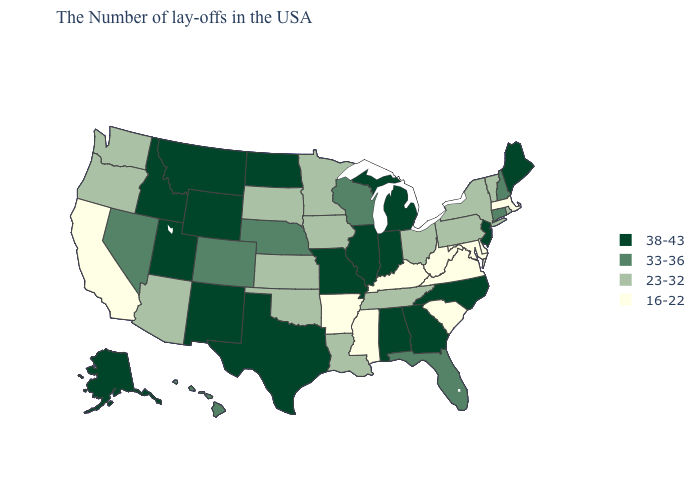What is the lowest value in the USA?
Quick response, please. 16-22. Does Pennsylvania have the lowest value in the USA?
Give a very brief answer. No. How many symbols are there in the legend?
Short answer required. 4. Does New Hampshire have the highest value in the Northeast?
Answer briefly. No. Name the states that have a value in the range 38-43?
Be succinct. Maine, New Jersey, North Carolina, Georgia, Michigan, Indiana, Alabama, Illinois, Missouri, Texas, North Dakota, Wyoming, New Mexico, Utah, Montana, Idaho, Alaska. Name the states that have a value in the range 33-36?
Give a very brief answer. New Hampshire, Connecticut, Florida, Wisconsin, Nebraska, Colorado, Nevada, Hawaii. Does South Dakota have a lower value than Utah?
Short answer required. Yes. What is the highest value in the USA?
Answer briefly. 38-43. Does Utah have a higher value than Washington?
Give a very brief answer. Yes. Which states have the lowest value in the USA?
Write a very short answer. Massachusetts, Delaware, Maryland, Virginia, South Carolina, West Virginia, Kentucky, Mississippi, Arkansas, California. What is the highest value in the MidWest ?
Quick response, please. 38-43. What is the highest value in states that border Montana?
Short answer required. 38-43. What is the highest value in the West ?
Concise answer only. 38-43. Name the states that have a value in the range 16-22?
Answer briefly. Massachusetts, Delaware, Maryland, Virginia, South Carolina, West Virginia, Kentucky, Mississippi, Arkansas, California. What is the lowest value in the USA?
Be succinct. 16-22. 